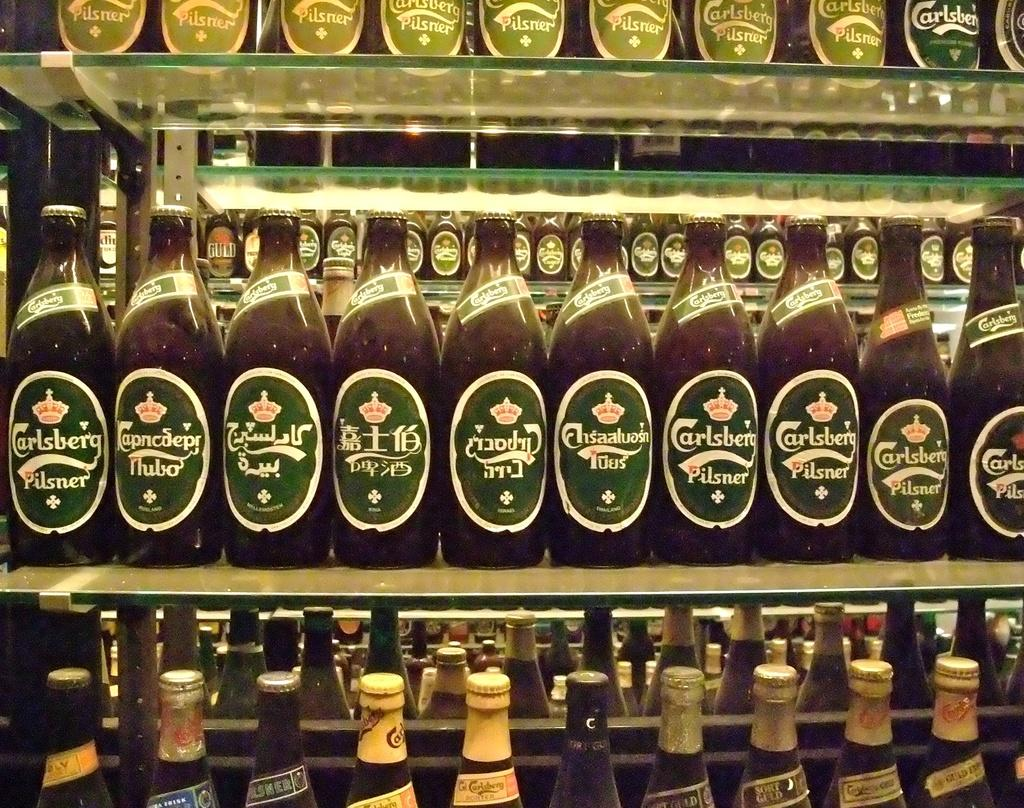What objects can be seen in the image? There are bottles in the image. What is the level of disgust that can be observed on the faces of the people in the image while they are handling the bottles? There are no people present in the image, only bottles. What type of wrench is being used to open the bottles in the image? There is no wrench present in the image; it only shows bottles. 